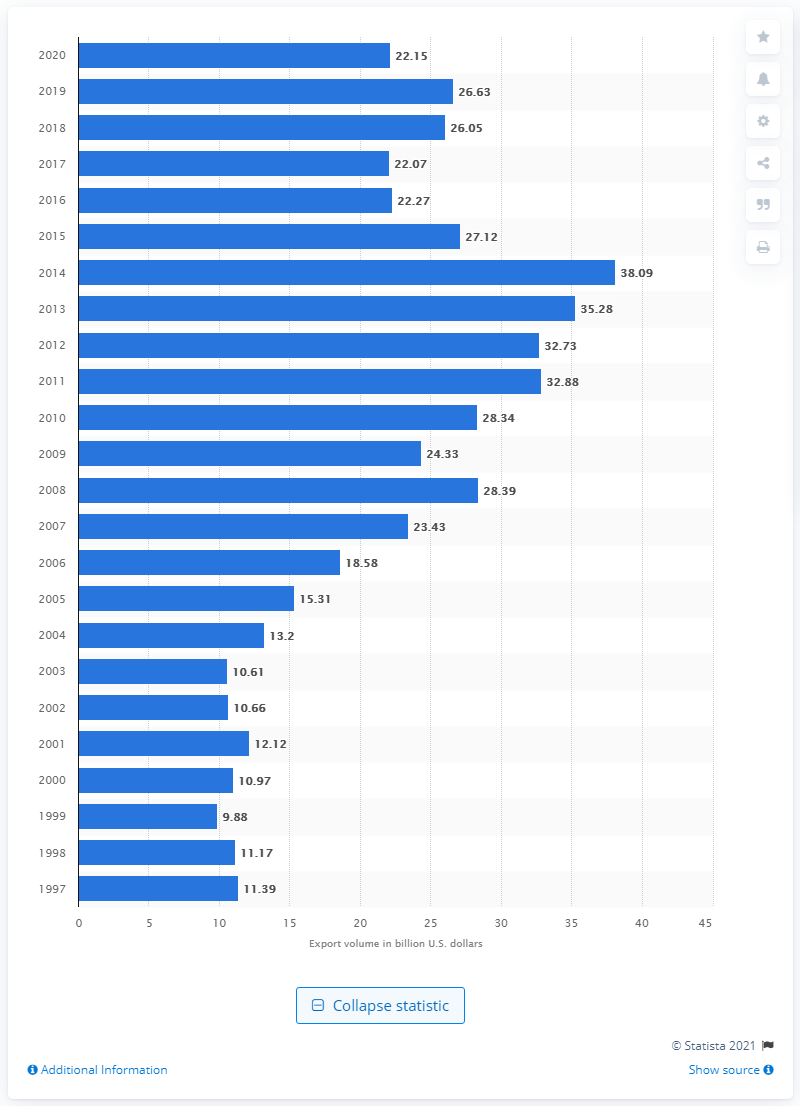List a handful of essential elements in this visual. The value of U.S. exports to Africa in 2020 was 22.15 billion dollars. 